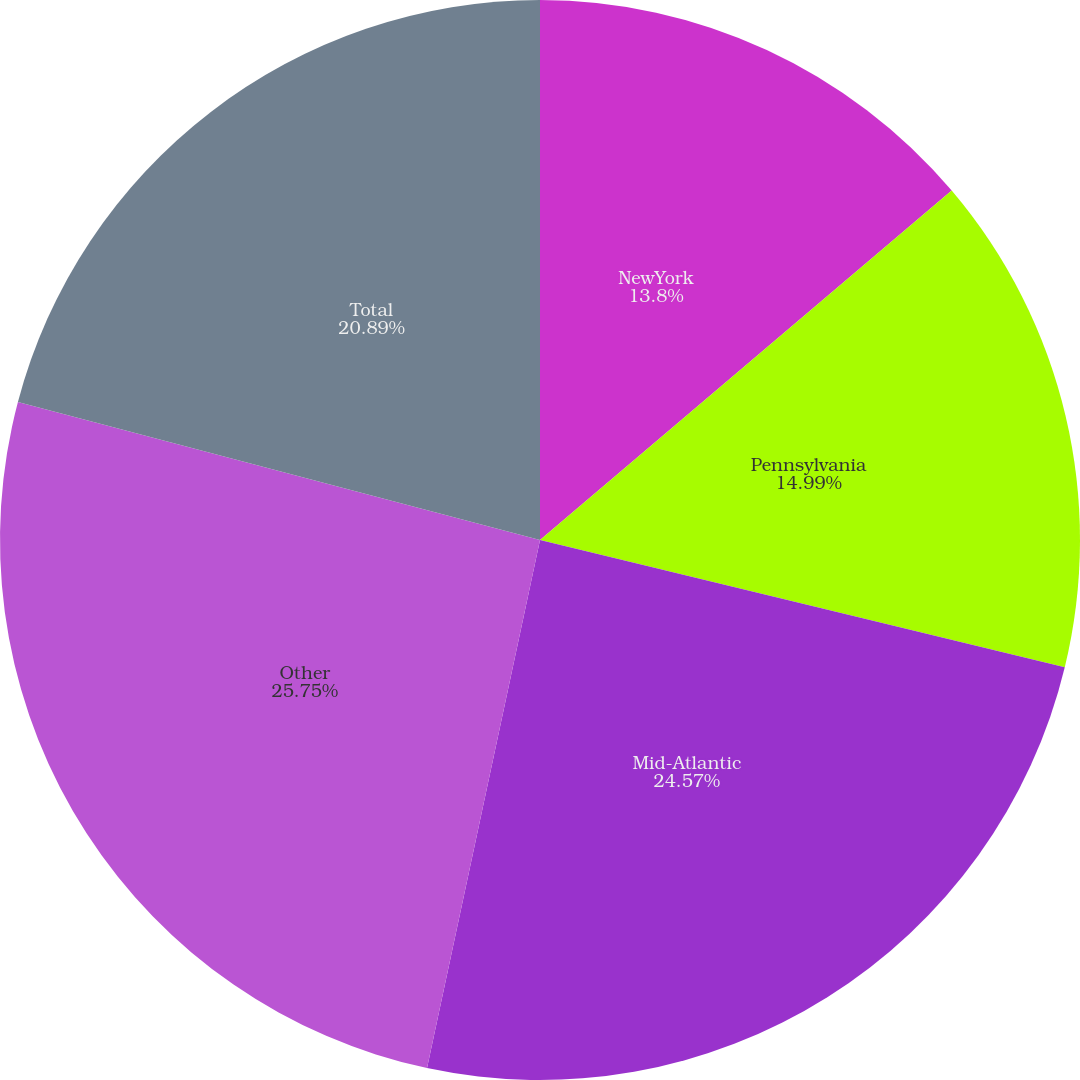Convert chart. <chart><loc_0><loc_0><loc_500><loc_500><pie_chart><fcel>NewYork<fcel>Pennsylvania<fcel>Mid-Atlantic<fcel>Other<fcel>Total<nl><fcel>13.8%<fcel>14.99%<fcel>24.57%<fcel>25.76%<fcel>20.89%<nl></chart> 